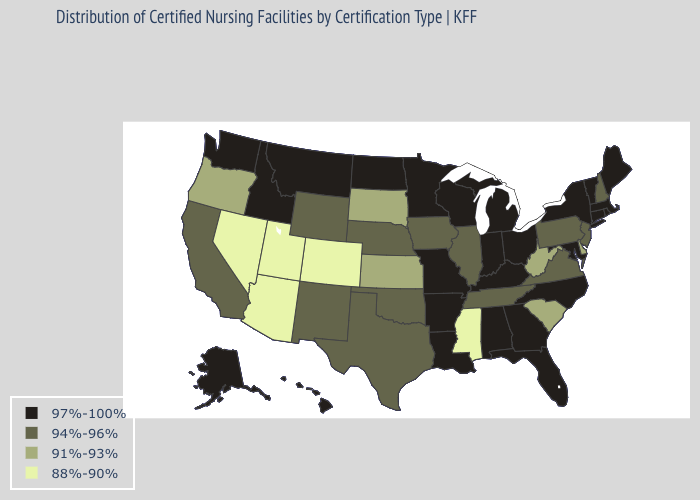What is the lowest value in states that border Georgia?
Be succinct. 91%-93%. Does North Dakota have the same value as South Carolina?
Quick response, please. No. What is the value of South Dakota?
Give a very brief answer. 91%-93%. Does New Mexico have a higher value than California?
Quick response, please. No. Name the states that have a value in the range 97%-100%?
Write a very short answer. Alabama, Alaska, Arkansas, Connecticut, Florida, Georgia, Hawaii, Idaho, Indiana, Kentucky, Louisiana, Maine, Maryland, Massachusetts, Michigan, Minnesota, Missouri, Montana, New York, North Carolina, North Dakota, Ohio, Rhode Island, Vermont, Washington, Wisconsin. What is the lowest value in the MidWest?
Answer briefly. 91%-93%. Does the map have missing data?
Short answer required. No. What is the value of Alaska?
Keep it brief. 97%-100%. Name the states that have a value in the range 97%-100%?
Keep it brief. Alabama, Alaska, Arkansas, Connecticut, Florida, Georgia, Hawaii, Idaho, Indiana, Kentucky, Louisiana, Maine, Maryland, Massachusetts, Michigan, Minnesota, Missouri, Montana, New York, North Carolina, North Dakota, Ohio, Rhode Island, Vermont, Washington, Wisconsin. Name the states that have a value in the range 97%-100%?
Answer briefly. Alabama, Alaska, Arkansas, Connecticut, Florida, Georgia, Hawaii, Idaho, Indiana, Kentucky, Louisiana, Maine, Maryland, Massachusetts, Michigan, Minnesota, Missouri, Montana, New York, North Carolina, North Dakota, Ohio, Rhode Island, Vermont, Washington, Wisconsin. What is the highest value in the South ?
Write a very short answer. 97%-100%. Name the states that have a value in the range 88%-90%?
Be succinct. Arizona, Colorado, Mississippi, Nevada, Utah. Name the states that have a value in the range 94%-96%?
Quick response, please. California, Illinois, Iowa, Nebraska, New Hampshire, New Jersey, New Mexico, Oklahoma, Pennsylvania, Tennessee, Texas, Virginia, Wyoming. Name the states that have a value in the range 94%-96%?
Be succinct. California, Illinois, Iowa, Nebraska, New Hampshire, New Jersey, New Mexico, Oklahoma, Pennsylvania, Tennessee, Texas, Virginia, Wyoming. Name the states that have a value in the range 94%-96%?
Concise answer only. California, Illinois, Iowa, Nebraska, New Hampshire, New Jersey, New Mexico, Oklahoma, Pennsylvania, Tennessee, Texas, Virginia, Wyoming. 